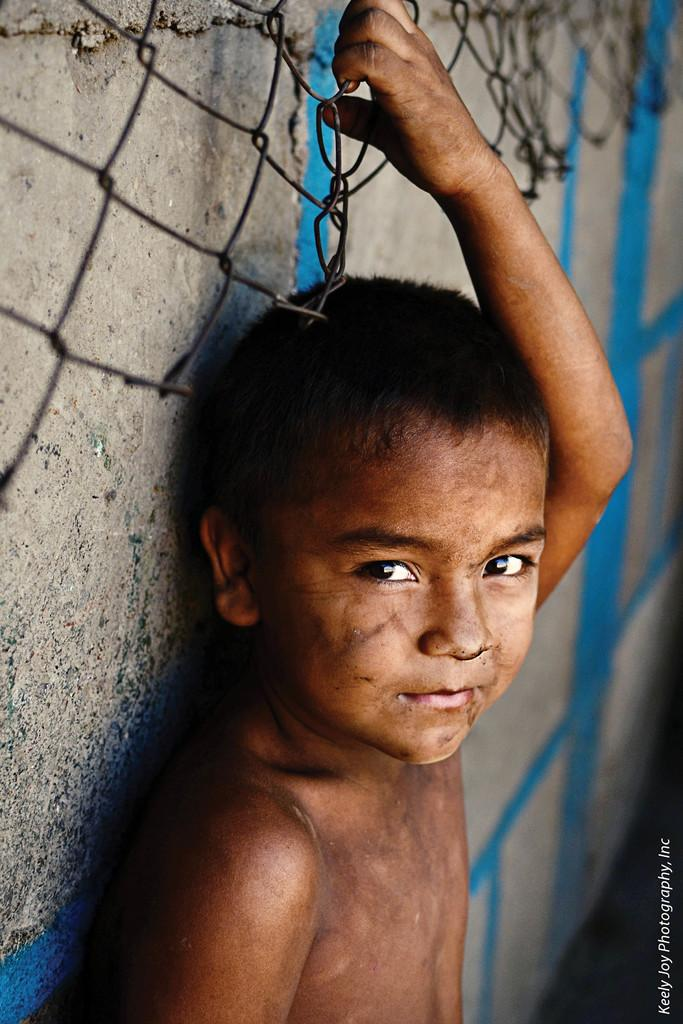What is the person in the image holding? The person is holding an iron net in the image. Can you describe the color of the wall in the image? The wall in the image has a grey and blue color. Is there any additional information or marking at the bottom of the image? Yes, there is a watermark at the bottom of the image. What type of lunch is the person eating in the image? There is no indication of the person eating lunch in the image. 